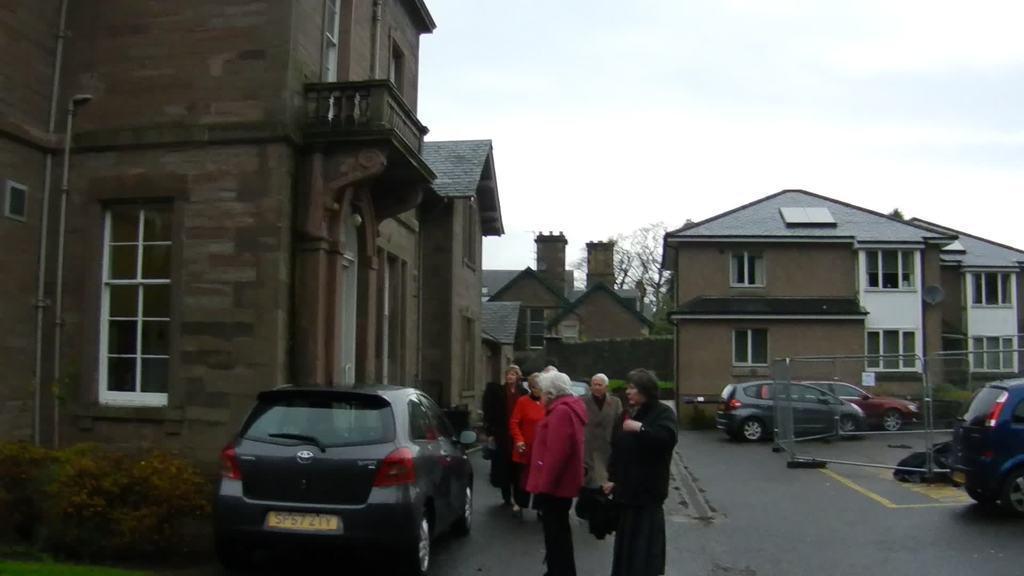In one or two sentences, can you explain what this image depicts? There are some persons, cars and plants present at the bottom of this image, and there are some buildings in the background. We can see a tree in the middle of this image and there is a sky at the top of this image. 